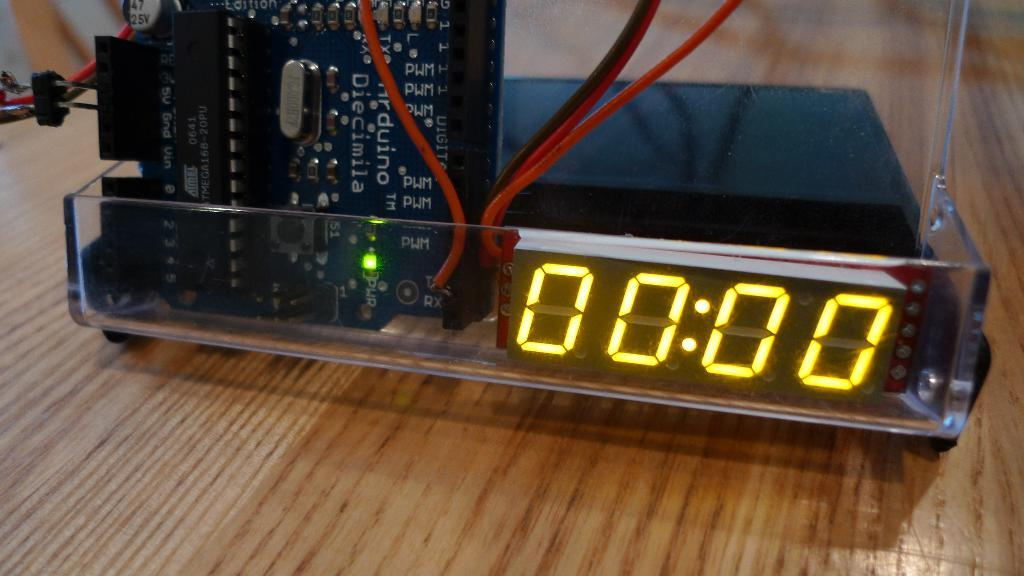<image>
Present a compact description of the photo's key features. a clock with 00.00 on it and red wires coming off it 